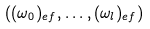Convert formula to latex. <formula><loc_0><loc_0><loc_500><loc_500>( ( \omega _ { 0 } ) _ { e f } , \dots , ( \omega _ { l } ) _ { e f } )</formula> 